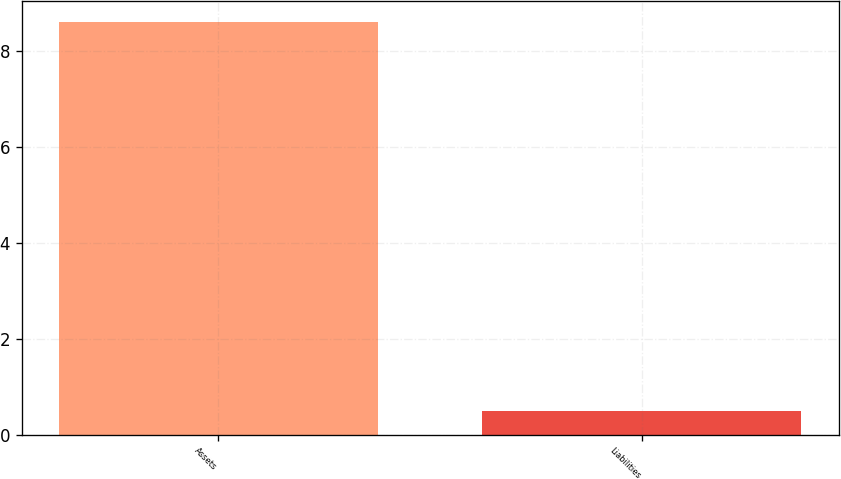Convert chart to OTSL. <chart><loc_0><loc_0><loc_500><loc_500><bar_chart><fcel>Assets<fcel>Liabilities<nl><fcel>8.6<fcel>0.5<nl></chart> 